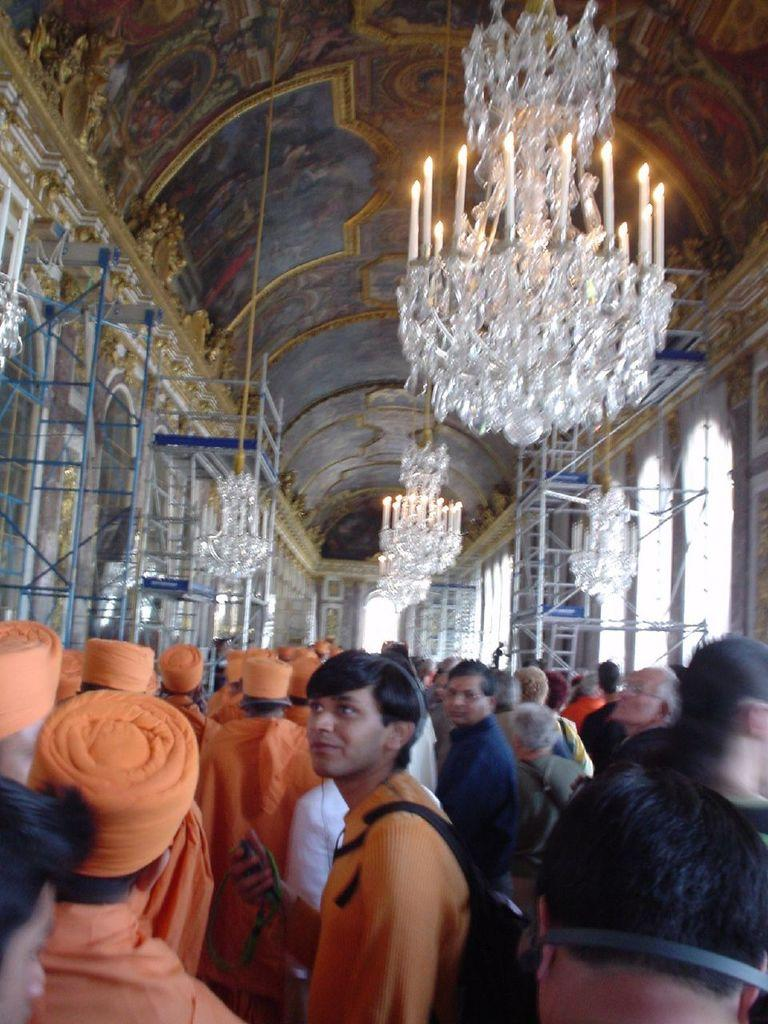How many people are at the bottom of the image? There are many people at the bottom of the image. What is located at the top of the image? There is a roof visible at the top of the image, along with chandeliers and candles. What type of objects are present on both sides of the image? Metal objects are present on both sides of the image. What type of dirt can be seen on the people's shirts in the image? There is no dirt visible on the people's shirts in the image. Can you tell me how many people are smiling in the image? The provided facts do not mention anything about the people's facial expressions, so it is impossible to determine how many people are smiling in the image. 